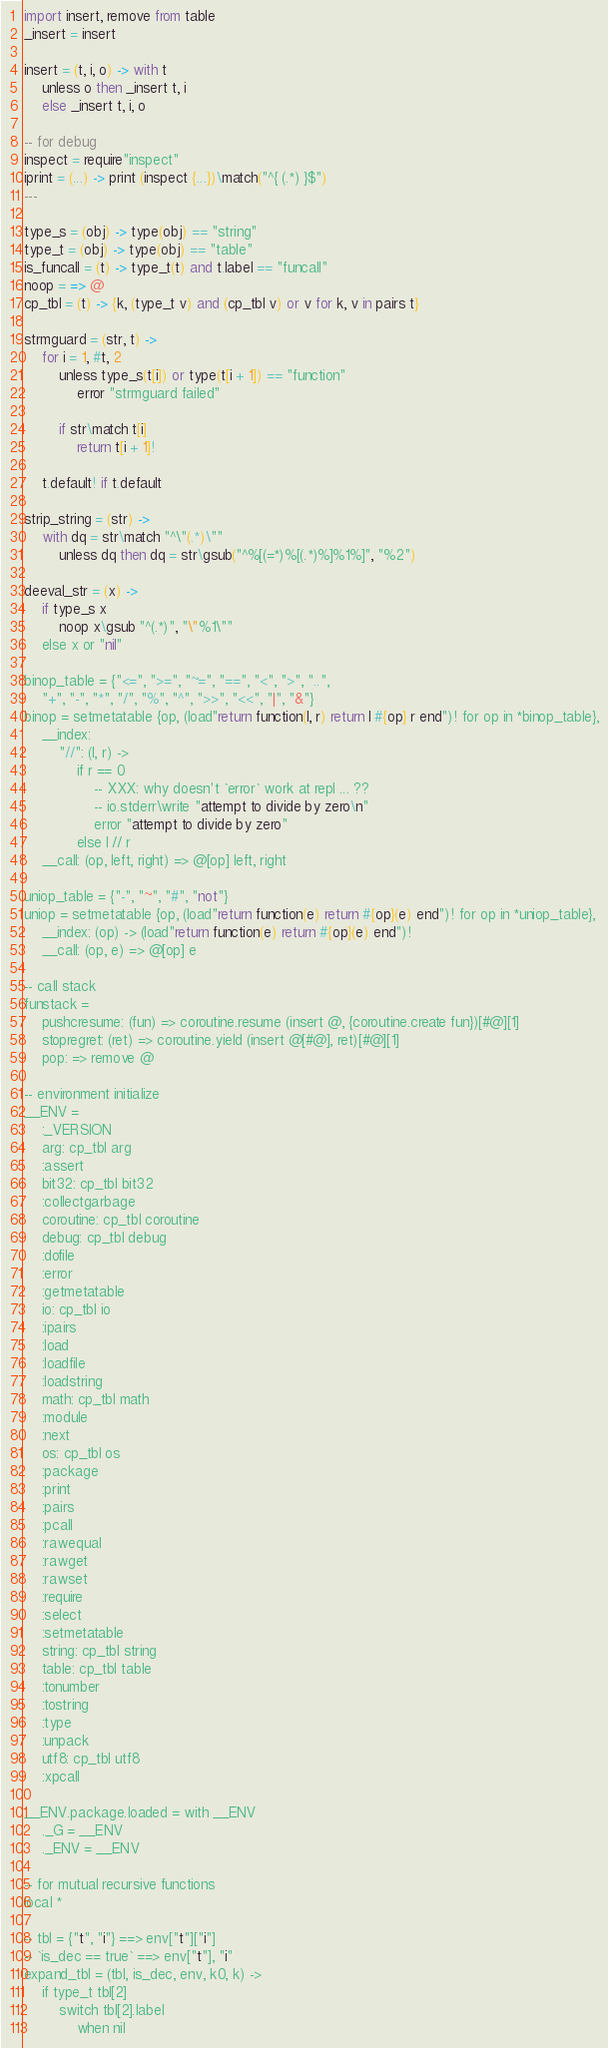<code> <loc_0><loc_0><loc_500><loc_500><_MoonScript_>import insert, remove from table
_insert = insert

insert = (t, i, o) -> with t
	unless o then _insert t, i
	else _insert t, i, o

-- for debug
inspect = require"inspect"
iprint = (...) -> print (inspect {...})\match("^{ (.*) }$")
---

type_s = (obj) -> type(obj) == "string"
type_t = (obj) -> type(obj) == "table"
is_funcall = (t) -> type_t(t) and t.label == "funcall"
noop = => @
cp_tbl = (t) -> {k, (type_t v) and (cp_tbl v) or v for k, v in pairs t}

strmguard = (str, t) ->
	for i = 1, #t, 2
		unless type_s(t[i]) or type(t[i + 1]) == "function"
			error "strmguard failed"

		if str\match t[i]
			return t[i + 1]!

	t.default! if t.default

strip_string = (str) ->
	with dq = str\match "^\"(.*)\""
		unless dq then dq = str\gsub("^%[(=*)%[(.*)%]%1%]", "%2")

deeval_str = (x) ->
	if type_s x
		noop x\gsub "^(.*)", "\"%1\""
	else x or "nil"

binop_table = {"<=", ">=", "~=", "==", "<", ">", "..",
	"+", "-", "*", "/", "%", "^", ">>", "<<", "|", "&"}
binop = setmetatable {op, (load"return function(l, r) return l #{op} r end")! for op in *binop_table},
	__index:
		"//": (l, r) ->
			if r == 0
				-- XXX: why doesn't `error` work at repl ... ??
				-- io.stderr\write "attempt to divide by zero\n"
				error "attempt to divide by zero"
			else l // r
	__call: (op, left, right) => @[op] left, right

uniop_table = {"-", "~", "#", "not"}
uniop = setmetatable {op, (load"return function(e) return #{op}(e) end")! for op in *uniop_table},
	__index: (op) -> (load"return function(e) return #{op}(e) end")!
	__call: (op, e) => @[op] e

-- call stack
funstack =
	pushcresume: (fun) => coroutine.resume (insert @, {coroutine.create fun})[#@][1]
	stopregret: (ret) => coroutine.yield (insert @[#@], ret)[#@][1]
	pop: => remove @

-- environment initialize
__ENV =
	:_VERSION
	arg: cp_tbl arg
	:assert
	bit32: cp_tbl bit32
	:collectgarbage
	coroutine: cp_tbl coroutine
	debug: cp_tbl debug
	:dofile
	:error
	:getmetatable
	io: cp_tbl io
	:ipairs
	:load
	:loadfile
	:loadstring
	math: cp_tbl math
	:module
	:next
	os: cp_tbl os
	:package
	:print
	:pairs
	:pcall
	:rawequal
	:rawget
	:rawset
	:require
	:select
	:setmetatable
	string: cp_tbl string
	table: cp_tbl table
	:tonumber
	:tostring
	:type
	:unpack
	utf8: cp_tbl utf8
	:xpcall

__ENV.package.loaded = with __ENV
	._G = __ENV
	._ENV = __ENV

-- for mutual recursive functions
local *

-- tbl = {"t", "i"} ==> env["t"]["i"]
-- `is_dec == true` ==> env["t"], "i"
expand_tbl = (tbl, is_dec, env, k0, k) ->
	if type_t tbl[2]
		switch tbl[2].label
			when nil</code> 